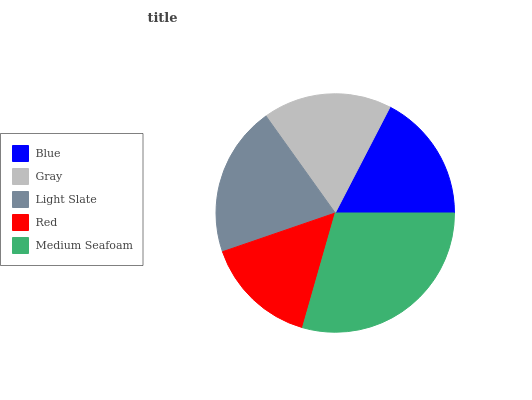Is Red the minimum?
Answer yes or no. Yes. Is Medium Seafoam the maximum?
Answer yes or no. Yes. Is Gray the minimum?
Answer yes or no. No. Is Gray the maximum?
Answer yes or no. No. Is Gray greater than Blue?
Answer yes or no. Yes. Is Blue less than Gray?
Answer yes or no. Yes. Is Blue greater than Gray?
Answer yes or no. No. Is Gray less than Blue?
Answer yes or no. No. Is Gray the high median?
Answer yes or no. Yes. Is Gray the low median?
Answer yes or no. Yes. Is Light Slate the high median?
Answer yes or no. No. Is Blue the low median?
Answer yes or no. No. 